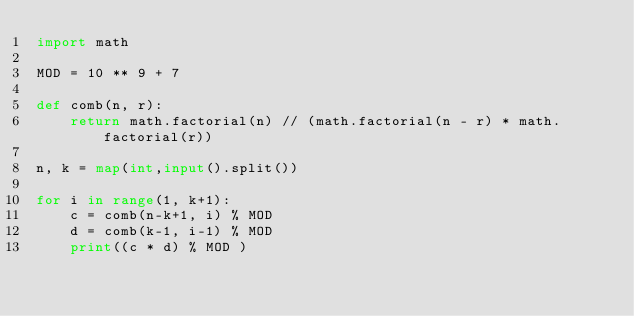Convert code to text. <code><loc_0><loc_0><loc_500><loc_500><_Python_>import math

MOD = 10 ** 9 + 7

def comb(n, r):
    return math.factorial(n) // (math.factorial(n - r) * math.factorial(r))

n, k = map(int,input().split())

for i in range(1, k+1):
    c = comb(n-k+1, i) % MOD
    d = comb(k-1, i-1) % MOD
    print((c * d) % MOD )
</code> 